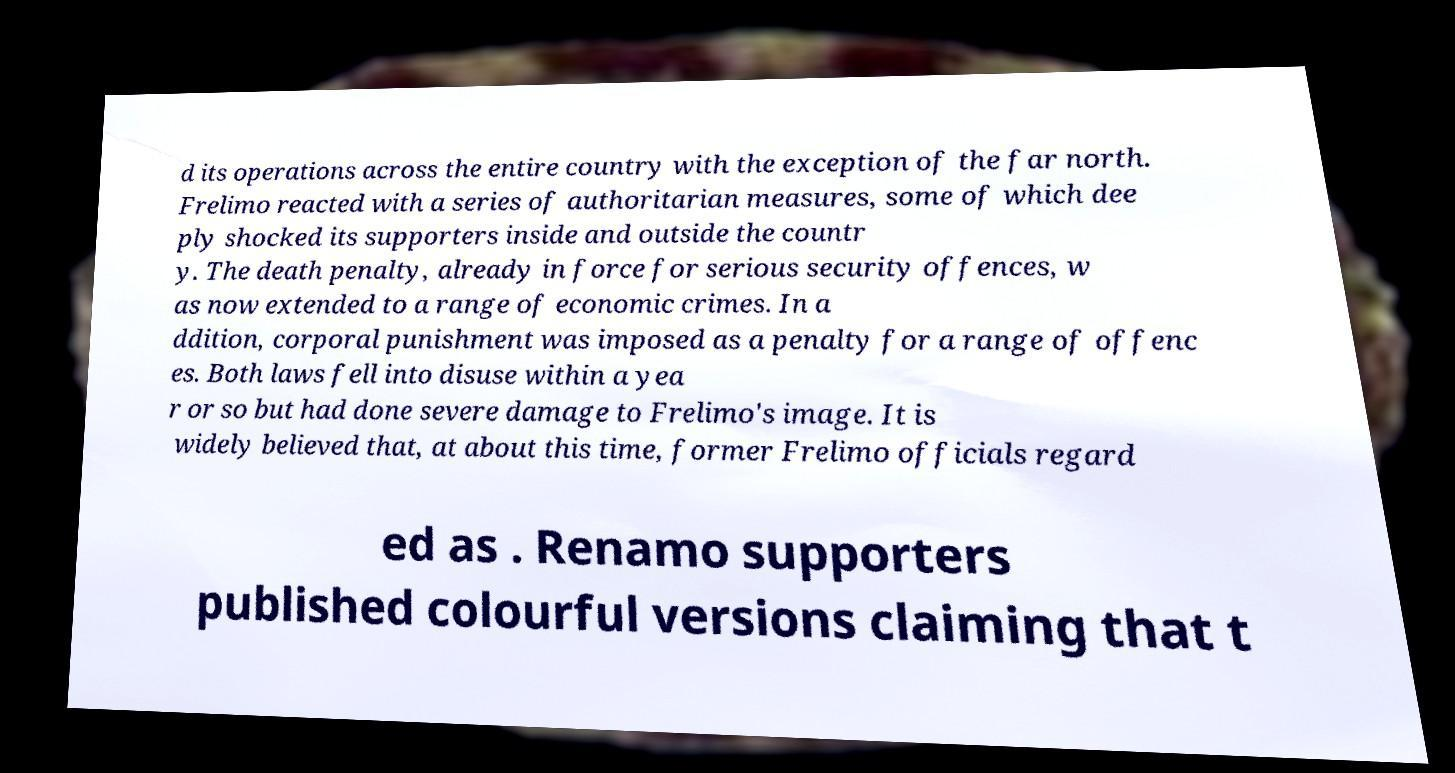Could you assist in decoding the text presented in this image and type it out clearly? d its operations across the entire country with the exception of the far north. Frelimo reacted with a series of authoritarian measures, some of which dee ply shocked its supporters inside and outside the countr y. The death penalty, already in force for serious security offences, w as now extended to a range of economic crimes. In a ddition, corporal punishment was imposed as a penalty for a range of offenc es. Both laws fell into disuse within a yea r or so but had done severe damage to Frelimo's image. It is widely believed that, at about this time, former Frelimo officials regard ed as . Renamo supporters published colourful versions claiming that t 